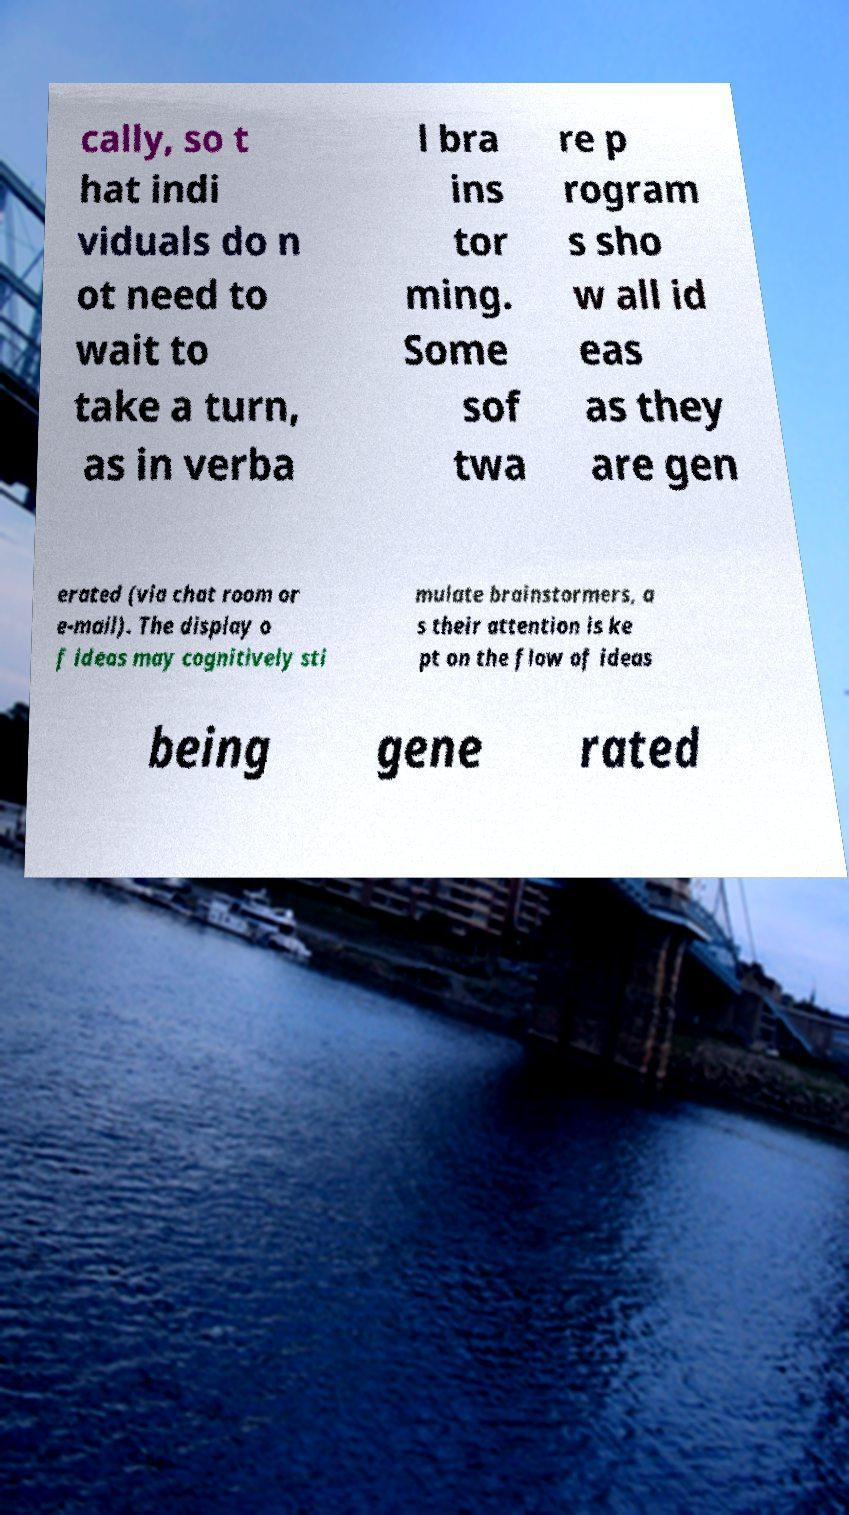Please read and relay the text visible in this image. What does it say? cally, so t hat indi viduals do n ot need to wait to take a turn, as in verba l bra ins tor ming. Some sof twa re p rogram s sho w all id eas as they are gen erated (via chat room or e-mail). The display o f ideas may cognitively sti mulate brainstormers, a s their attention is ke pt on the flow of ideas being gene rated 